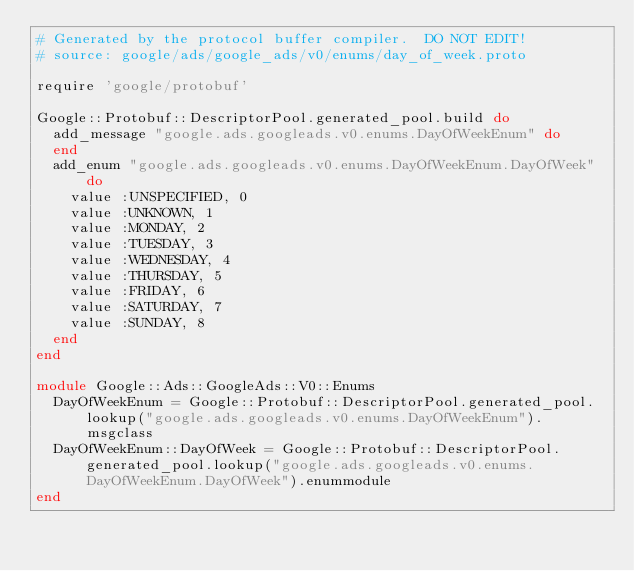Convert code to text. <code><loc_0><loc_0><loc_500><loc_500><_Ruby_># Generated by the protocol buffer compiler.  DO NOT EDIT!
# source: google/ads/google_ads/v0/enums/day_of_week.proto

require 'google/protobuf'

Google::Protobuf::DescriptorPool.generated_pool.build do
  add_message "google.ads.googleads.v0.enums.DayOfWeekEnum" do
  end
  add_enum "google.ads.googleads.v0.enums.DayOfWeekEnum.DayOfWeek" do
    value :UNSPECIFIED, 0
    value :UNKNOWN, 1
    value :MONDAY, 2
    value :TUESDAY, 3
    value :WEDNESDAY, 4
    value :THURSDAY, 5
    value :FRIDAY, 6
    value :SATURDAY, 7
    value :SUNDAY, 8
  end
end

module Google::Ads::GoogleAds::V0::Enums
  DayOfWeekEnum = Google::Protobuf::DescriptorPool.generated_pool.lookup("google.ads.googleads.v0.enums.DayOfWeekEnum").msgclass
  DayOfWeekEnum::DayOfWeek = Google::Protobuf::DescriptorPool.generated_pool.lookup("google.ads.googleads.v0.enums.DayOfWeekEnum.DayOfWeek").enummodule
end
</code> 